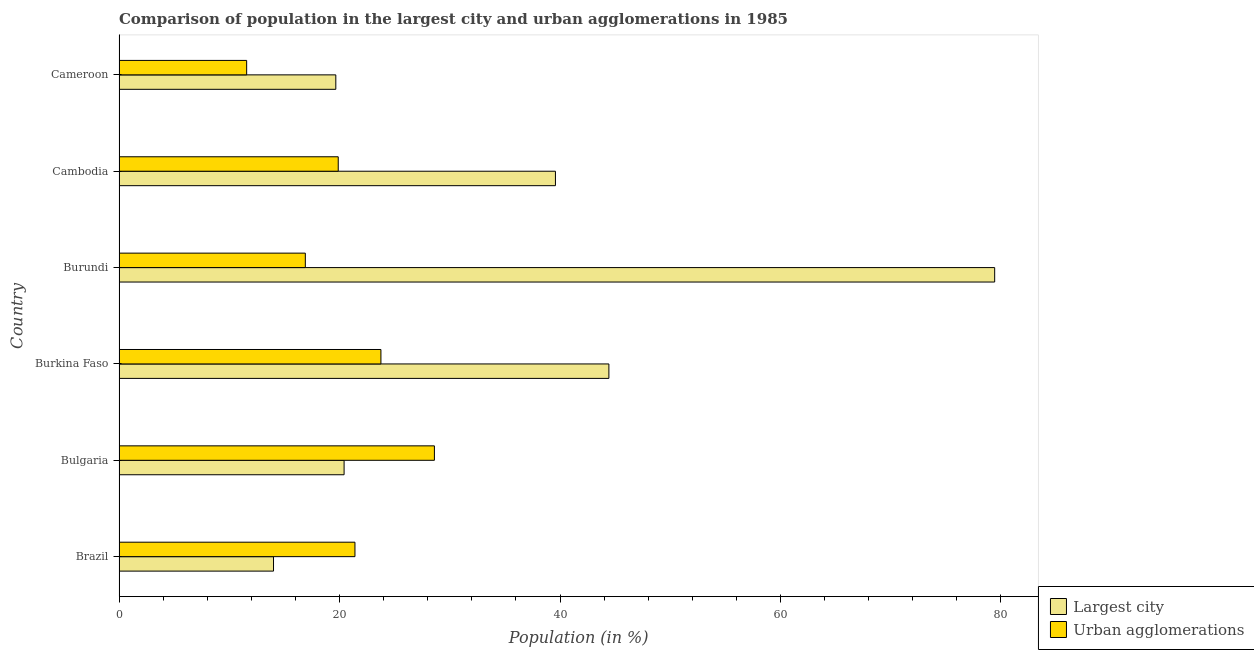How many different coloured bars are there?
Keep it short and to the point. 2. How many groups of bars are there?
Ensure brevity in your answer.  6. Are the number of bars on each tick of the Y-axis equal?
Your answer should be compact. Yes. How many bars are there on the 4th tick from the bottom?
Your answer should be very brief. 2. What is the label of the 1st group of bars from the top?
Ensure brevity in your answer.  Cameroon. What is the population in urban agglomerations in Burkina Faso?
Give a very brief answer. 23.76. Across all countries, what is the maximum population in the largest city?
Provide a succinct answer. 79.43. Across all countries, what is the minimum population in urban agglomerations?
Your response must be concise. 11.57. What is the total population in urban agglomerations in the graph?
Make the answer very short. 122.12. What is the difference between the population in the largest city in Burkina Faso and that in Burundi?
Your answer should be very brief. -34.99. What is the difference between the population in urban agglomerations in Brazil and the population in the largest city in Cambodia?
Your answer should be compact. -18.19. What is the average population in the largest city per country?
Give a very brief answer. 36.26. What is the difference between the population in the largest city and population in urban agglomerations in Burundi?
Make the answer very short. 62.53. What is the ratio of the population in urban agglomerations in Cambodia to that in Cameroon?
Offer a very short reply. 1.72. Is the population in urban agglomerations in Bulgaria less than that in Burkina Faso?
Provide a short and direct response. No. What is the difference between the highest and the second highest population in urban agglomerations?
Keep it short and to the point. 4.85. What is the difference between the highest and the lowest population in urban agglomerations?
Your answer should be very brief. 17.03. In how many countries, is the population in urban agglomerations greater than the average population in urban agglomerations taken over all countries?
Your response must be concise. 3. What does the 2nd bar from the top in Bulgaria represents?
Give a very brief answer. Largest city. What does the 1st bar from the bottom in Bulgaria represents?
Make the answer very short. Largest city. Are all the bars in the graph horizontal?
Make the answer very short. Yes. What is the difference between two consecutive major ticks on the X-axis?
Offer a very short reply. 20. How many legend labels are there?
Offer a very short reply. 2. How are the legend labels stacked?
Your response must be concise. Vertical. What is the title of the graph?
Ensure brevity in your answer.  Comparison of population in the largest city and urban agglomerations in 1985. What is the label or title of the X-axis?
Provide a short and direct response. Population (in %). What is the Population (in %) in Largest city in Brazil?
Provide a short and direct response. 14.01. What is the Population (in %) of Urban agglomerations in Brazil?
Provide a succinct answer. 21.4. What is the Population (in %) in Largest city in Bulgaria?
Offer a terse response. 20.41. What is the Population (in %) of Urban agglomerations in Bulgaria?
Offer a very short reply. 28.61. What is the Population (in %) of Largest city in Burkina Faso?
Your response must be concise. 44.43. What is the Population (in %) of Urban agglomerations in Burkina Faso?
Your response must be concise. 23.76. What is the Population (in %) of Largest city in Burundi?
Provide a succinct answer. 79.43. What is the Population (in %) of Urban agglomerations in Burundi?
Ensure brevity in your answer.  16.9. What is the Population (in %) of Largest city in Cambodia?
Your answer should be very brief. 39.59. What is the Population (in %) of Urban agglomerations in Cambodia?
Offer a terse response. 19.88. What is the Population (in %) of Largest city in Cameroon?
Your answer should be very brief. 19.66. What is the Population (in %) of Urban agglomerations in Cameroon?
Make the answer very short. 11.57. Across all countries, what is the maximum Population (in %) of Largest city?
Ensure brevity in your answer.  79.43. Across all countries, what is the maximum Population (in %) in Urban agglomerations?
Your answer should be compact. 28.61. Across all countries, what is the minimum Population (in %) in Largest city?
Ensure brevity in your answer.  14.01. Across all countries, what is the minimum Population (in %) of Urban agglomerations?
Provide a short and direct response. 11.57. What is the total Population (in %) in Largest city in the graph?
Offer a terse response. 217.54. What is the total Population (in %) in Urban agglomerations in the graph?
Your response must be concise. 122.12. What is the difference between the Population (in %) in Largest city in Brazil and that in Bulgaria?
Your response must be concise. -6.4. What is the difference between the Population (in %) of Urban agglomerations in Brazil and that in Bulgaria?
Keep it short and to the point. -7.21. What is the difference between the Population (in %) of Largest city in Brazil and that in Burkina Faso?
Offer a terse response. -30.42. What is the difference between the Population (in %) of Urban agglomerations in Brazil and that in Burkina Faso?
Offer a terse response. -2.36. What is the difference between the Population (in %) in Largest city in Brazil and that in Burundi?
Make the answer very short. -65.42. What is the difference between the Population (in %) in Urban agglomerations in Brazil and that in Burundi?
Ensure brevity in your answer.  4.5. What is the difference between the Population (in %) in Largest city in Brazil and that in Cambodia?
Provide a succinct answer. -25.57. What is the difference between the Population (in %) in Urban agglomerations in Brazil and that in Cambodia?
Provide a short and direct response. 1.52. What is the difference between the Population (in %) in Largest city in Brazil and that in Cameroon?
Your response must be concise. -5.65. What is the difference between the Population (in %) in Urban agglomerations in Brazil and that in Cameroon?
Keep it short and to the point. 9.82. What is the difference between the Population (in %) of Largest city in Bulgaria and that in Burkina Faso?
Ensure brevity in your answer.  -24.02. What is the difference between the Population (in %) in Urban agglomerations in Bulgaria and that in Burkina Faso?
Offer a terse response. 4.85. What is the difference between the Population (in %) of Largest city in Bulgaria and that in Burundi?
Provide a succinct answer. -59.02. What is the difference between the Population (in %) in Urban agglomerations in Bulgaria and that in Burundi?
Offer a terse response. 11.71. What is the difference between the Population (in %) in Largest city in Bulgaria and that in Cambodia?
Ensure brevity in your answer.  -19.17. What is the difference between the Population (in %) of Urban agglomerations in Bulgaria and that in Cambodia?
Make the answer very short. 8.72. What is the difference between the Population (in %) of Largest city in Bulgaria and that in Cameroon?
Give a very brief answer. 0.75. What is the difference between the Population (in %) of Urban agglomerations in Bulgaria and that in Cameroon?
Your response must be concise. 17.03. What is the difference between the Population (in %) of Largest city in Burkina Faso and that in Burundi?
Your response must be concise. -34.99. What is the difference between the Population (in %) in Urban agglomerations in Burkina Faso and that in Burundi?
Give a very brief answer. 6.86. What is the difference between the Population (in %) in Largest city in Burkina Faso and that in Cambodia?
Your response must be concise. 4.85. What is the difference between the Population (in %) in Urban agglomerations in Burkina Faso and that in Cambodia?
Keep it short and to the point. 3.87. What is the difference between the Population (in %) in Largest city in Burkina Faso and that in Cameroon?
Ensure brevity in your answer.  24.77. What is the difference between the Population (in %) of Urban agglomerations in Burkina Faso and that in Cameroon?
Make the answer very short. 12.18. What is the difference between the Population (in %) in Largest city in Burundi and that in Cambodia?
Offer a terse response. 39.84. What is the difference between the Population (in %) of Urban agglomerations in Burundi and that in Cambodia?
Offer a terse response. -2.98. What is the difference between the Population (in %) of Largest city in Burundi and that in Cameroon?
Keep it short and to the point. 59.77. What is the difference between the Population (in %) of Urban agglomerations in Burundi and that in Cameroon?
Ensure brevity in your answer.  5.32. What is the difference between the Population (in %) in Largest city in Cambodia and that in Cameroon?
Ensure brevity in your answer.  19.92. What is the difference between the Population (in %) of Urban agglomerations in Cambodia and that in Cameroon?
Your response must be concise. 8.31. What is the difference between the Population (in %) of Largest city in Brazil and the Population (in %) of Urban agglomerations in Bulgaria?
Your response must be concise. -14.59. What is the difference between the Population (in %) in Largest city in Brazil and the Population (in %) in Urban agglomerations in Burkina Faso?
Ensure brevity in your answer.  -9.74. What is the difference between the Population (in %) of Largest city in Brazil and the Population (in %) of Urban agglomerations in Burundi?
Offer a terse response. -2.89. What is the difference between the Population (in %) of Largest city in Brazil and the Population (in %) of Urban agglomerations in Cambodia?
Give a very brief answer. -5.87. What is the difference between the Population (in %) in Largest city in Brazil and the Population (in %) in Urban agglomerations in Cameroon?
Give a very brief answer. 2.44. What is the difference between the Population (in %) of Largest city in Bulgaria and the Population (in %) of Urban agglomerations in Burkina Faso?
Your response must be concise. -3.34. What is the difference between the Population (in %) in Largest city in Bulgaria and the Population (in %) in Urban agglomerations in Burundi?
Make the answer very short. 3.52. What is the difference between the Population (in %) of Largest city in Bulgaria and the Population (in %) of Urban agglomerations in Cambodia?
Your response must be concise. 0.53. What is the difference between the Population (in %) in Largest city in Bulgaria and the Population (in %) in Urban agglomerations in Cameroon?
Offer a very short reply. 8.84. What is the difference between the Population (in %) in Largest city in Burkina Faso and the Population (in %) in Urban agglomerations in Burundi?
Your answer should be very brief. 27.54. What is the difference between the Population (in %) of Largest city in Burkina Faso and the Population (in %) of Urban agglomerations in Cambodia?
Provide a short and direct response. 24.55. What is the difference between the Population (in %) in Largest city in Burkina Faso and the Population (in %) in Urban agglomerations in Cameroon?
Your response must be concise. 32.86. What is the difference between the Population (in %) of Largest city in Burundi and the Population (in %) of Urban agglomerations in Cambodia?
Offer a terse response. 59.55. What is the difference between the Population (in %) in Largest city in Burundi and the Population (in %) in Urban agglomerations in Cameroon?
Keep it short and to the point. 67.85. What is the difference between the Population (in %) of Largest city in Cambodia and the Population (in %) of Urban agglomerations in Cameroon?
Your answer should be very brief. 28.01. What is the average Population (in %) in Largest city per country?
Make the answer very short. 36.26. What is the average Population (in %) in Urban agglomerations per country?
Your response must be concise. 20.35. What is the difference between the Population (in %) in Largest city and Population (in %) in Urban agglomerations in Brazil?
Keep it short and to the point. -7.39. What is the difference between the Population (in %) in Largest city and Population (in %) in Urban agglomerations in Bulgaria?
Offer a very short reply. -8.19. What is the difference between the Population (in %) in Largest city and Population (in %) in Urban agglomerations in Burkina Faso?
Give a very brief answer. 20.68. What is the difference between the Population (in %) of Largest city and Population (in %) of Urban agglomerations in Burundi?
Make the answer very short. 62.53. What is the difference between the Population (in %) in Largest city and Population (in %) in Urban agglomerations in Cambodia?
Make the answer very short. 19.7. What is the difference between the Population (in %) in Largest city and Population (in %) in Urban agglomerations in Cameroon?
Make the answer very short. 8.09. What is the ratio of the Population (in %) in Largest city in Brazil to that in Bulgaria?
Give a very brief answer. 0.69. What is the ratio of the Population (in %) in Urban agglomerations in Brazil to that in Bulgaria?
Give a very brief answer. 0.75. What is the ratio of the Population (in %) in Largest city in Brazil to that in Burkina Faso?
Provide a succinct answer. 0.32. What is the ratio of the Population (in %) of Urban agglomerations in Brazil to that in Burkina Faso?
Your response must be concise. 0.9. What is the ratio of the Population (in %) of Largest city in Brazil to that in Burundi?
Your response must be concise. 0.18. What is the ratio of the Population (in %) in Urban agglomerations in Brazil to that in Burundi?
Give a very brief answer. 1.27. What is the ratio of the Population (in %) in Largest city in Brazil to that in Cambodia?
Provide a short and direct response. 0.35. What is the ratio of the Population (in %) in Urban agglomerations in Brazil to that in Cambodia?
Ensure brevity in your answer.  1.08. What is the ratio of the Population (in %) in Largest city in Brazil to that in Cameroon?
Your answer should be very brief. 0.71. What is the ratio of the Population (in %) in Urban agglomerations in Brazil to that in Cameroon?
Keep it short and to the point. 1.85. What is the ratio of the Population (in %) in Largest city in Bulgaria to that in Burkina Faso?
Give a very brief answer. 0.46. What is the ratio of the Population (in %) of Urban agglomerations in Bulgaria to that in Burkina Faso?
Keep it short and to the point. 1.2. What is the ratio of the Population (in %) in Largest city in Bulgaria to that in Burundi?
Provide a short and direct response. 0.26. What is the ratio of the Population (in %) of Urban agglomerations in Bulgaria to that in Burundi?
Provide a succinct answer. 1.69. What is the ratio of the Population (in %) of Largest city in Bulgaria to that in Cambodia?
Make the answer very short. 0.52. What is the ratio of the Population (in %) of Urban agglomerations in Bulgaria to that in Cambodia?
Make the answer very short. 1.44. What is the ratio of the Population (in %) in Largest city in Bulgaria to that in Cameroon?
Keep it short and to the point. 1.04. What is the ratio of the Population (in %) in Urban agglomerations in Bulgaria to that in Cameroon?
Provide a short and direct response. 2.47. What is the ratio of the Population (in %) in Largest city in Burkina Faso to that in Burundi?
Keep it short and to the point. 0.56. What is the ratio of the Population (in %) of Urban agglomerations in Burkina Faso to that in Burundi?
Make the answer very short. 1.41. What is the ratio of the Population (in %) in Largest city in Burkina Faso to that in Cambodia?
Provide a short and direct response. 1.12. What is the ratio of the Population (in %) of Urban agglomerations in Burkina Faso to that in Cambodia?
Keep it short and to the point. 1.19. What is the ratio of the Population (in %) of Largest city in Burkina Faso to that in Cameroon?
Provide a succinct answer. 2.26. What is the ratio of the Population (in %) of Urban agglomerations in Burkina Faso to that in Cameroon?
Offer a very short reply. 2.05. What is the ratio of the Population (in %) of Largest city in Burundi to that in Cambodia?
Make the answer very short. 2.01. What is the ratio of the Population (in %) of Urban agglomerations in Burundi to that in Cambodia?
Your response must be concise. 0.85. What is the ratio of the Population (in %) in Largest city in Burundi to that in Cameroon?
Provide a succinct answer. 4.04. What is the ratio of the Population (in %) of Urban agglomerations in Burundi to that in Cameroon?
Your answer should be compact. 1.46. What is the ratio of the Population (in %) of Largest city in Cambodia to that in Cameroon?
Keep it short and to the point. 2.01. What is the ratio of the Population (in %) in Urban agglomerations in Cambodia to that in Cameroon?
Provide a succinct answer. 1.72. What is the difference between the highest and the second highest Population (in %) of Largest city?
Offer a very short reply. 34.99. What is the difference between the highest and the second highest Population (in %) in Urban agglomerations?
Give a very brief answer. 4.85. What is the difference between the highest and the lowest Population (in %) of Largest city?
Keep it short and to the point. 65.42. What is the difference between the highest and the lowest Population (in %) of Urban agglomerations?
Ensure brevity in your answer.  17.03. 